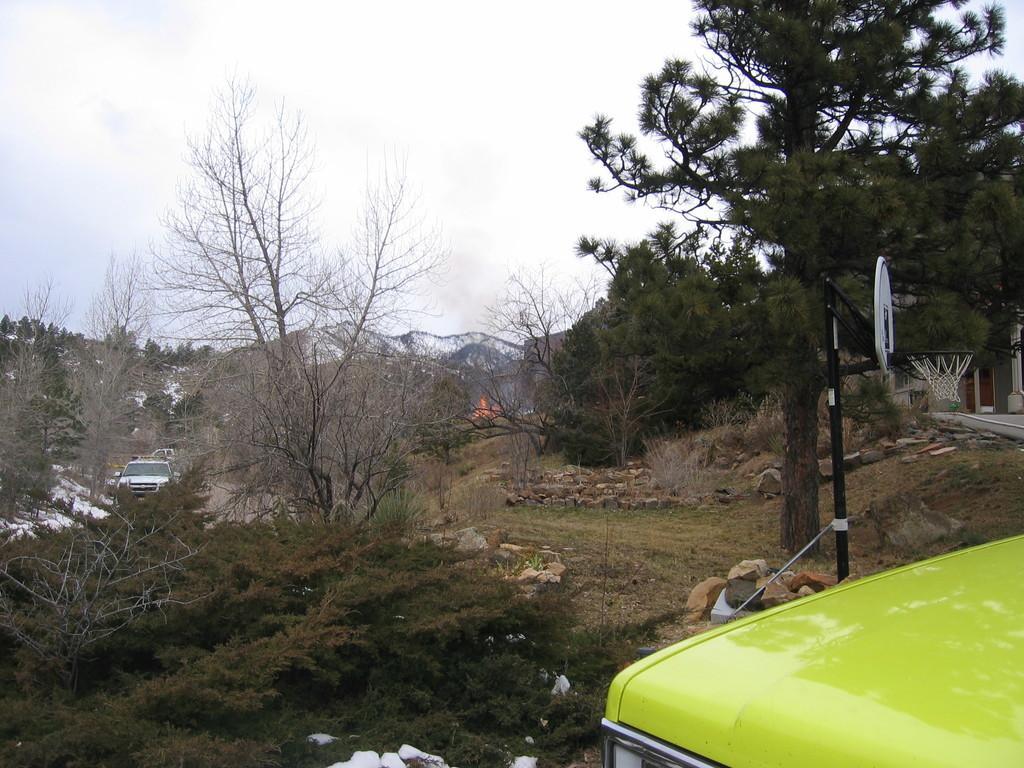In one or two sentences, can you explain what this image depicts? On the right side of the image we can see a vehicle. In the center there are trees and we can see a pole. There is a hoop. On the left we can see a car. In the background there are hills and sky. 